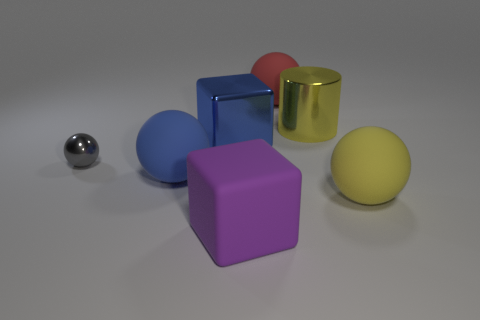How many rubber things are either cubes or big yellow cylinders?
Give a very brief answer. 1. Is there a tiny gray thing made of the same material as the big red object?
Keep it short and to the point. No. What material is the large purple block?
Give a very brief answer. Rubber. What shape is the big yellow object that is left of the yellow ball that is right of the cube that is behind the big blue rubber ball?
Offer a very short reply. Cylinder. Are there more blocks that are behind the large purple rubber cube than small red metallic cylinders?
Ensure brevity in your answer.  Yes. Do the red thing and the large object on the left side of the large blue block have the same shape?
Provide a short and direct response. Yes. There is a rubber object that is the same color as the metallic cube; what shape is it?
Make the answer very short. Sphere. What number of big yellow metal things are in front of the rubber thing on the left side of the large metal thing that is to the left of the big red ball?
Offer a very short reply. 0. What color is the cylinder that is the same size as the purple rubber thing?
Make the answer very short. Yellow. What size is the purple thing right of the cube behind the small metal ball?
Your answer should be compact. Large. 